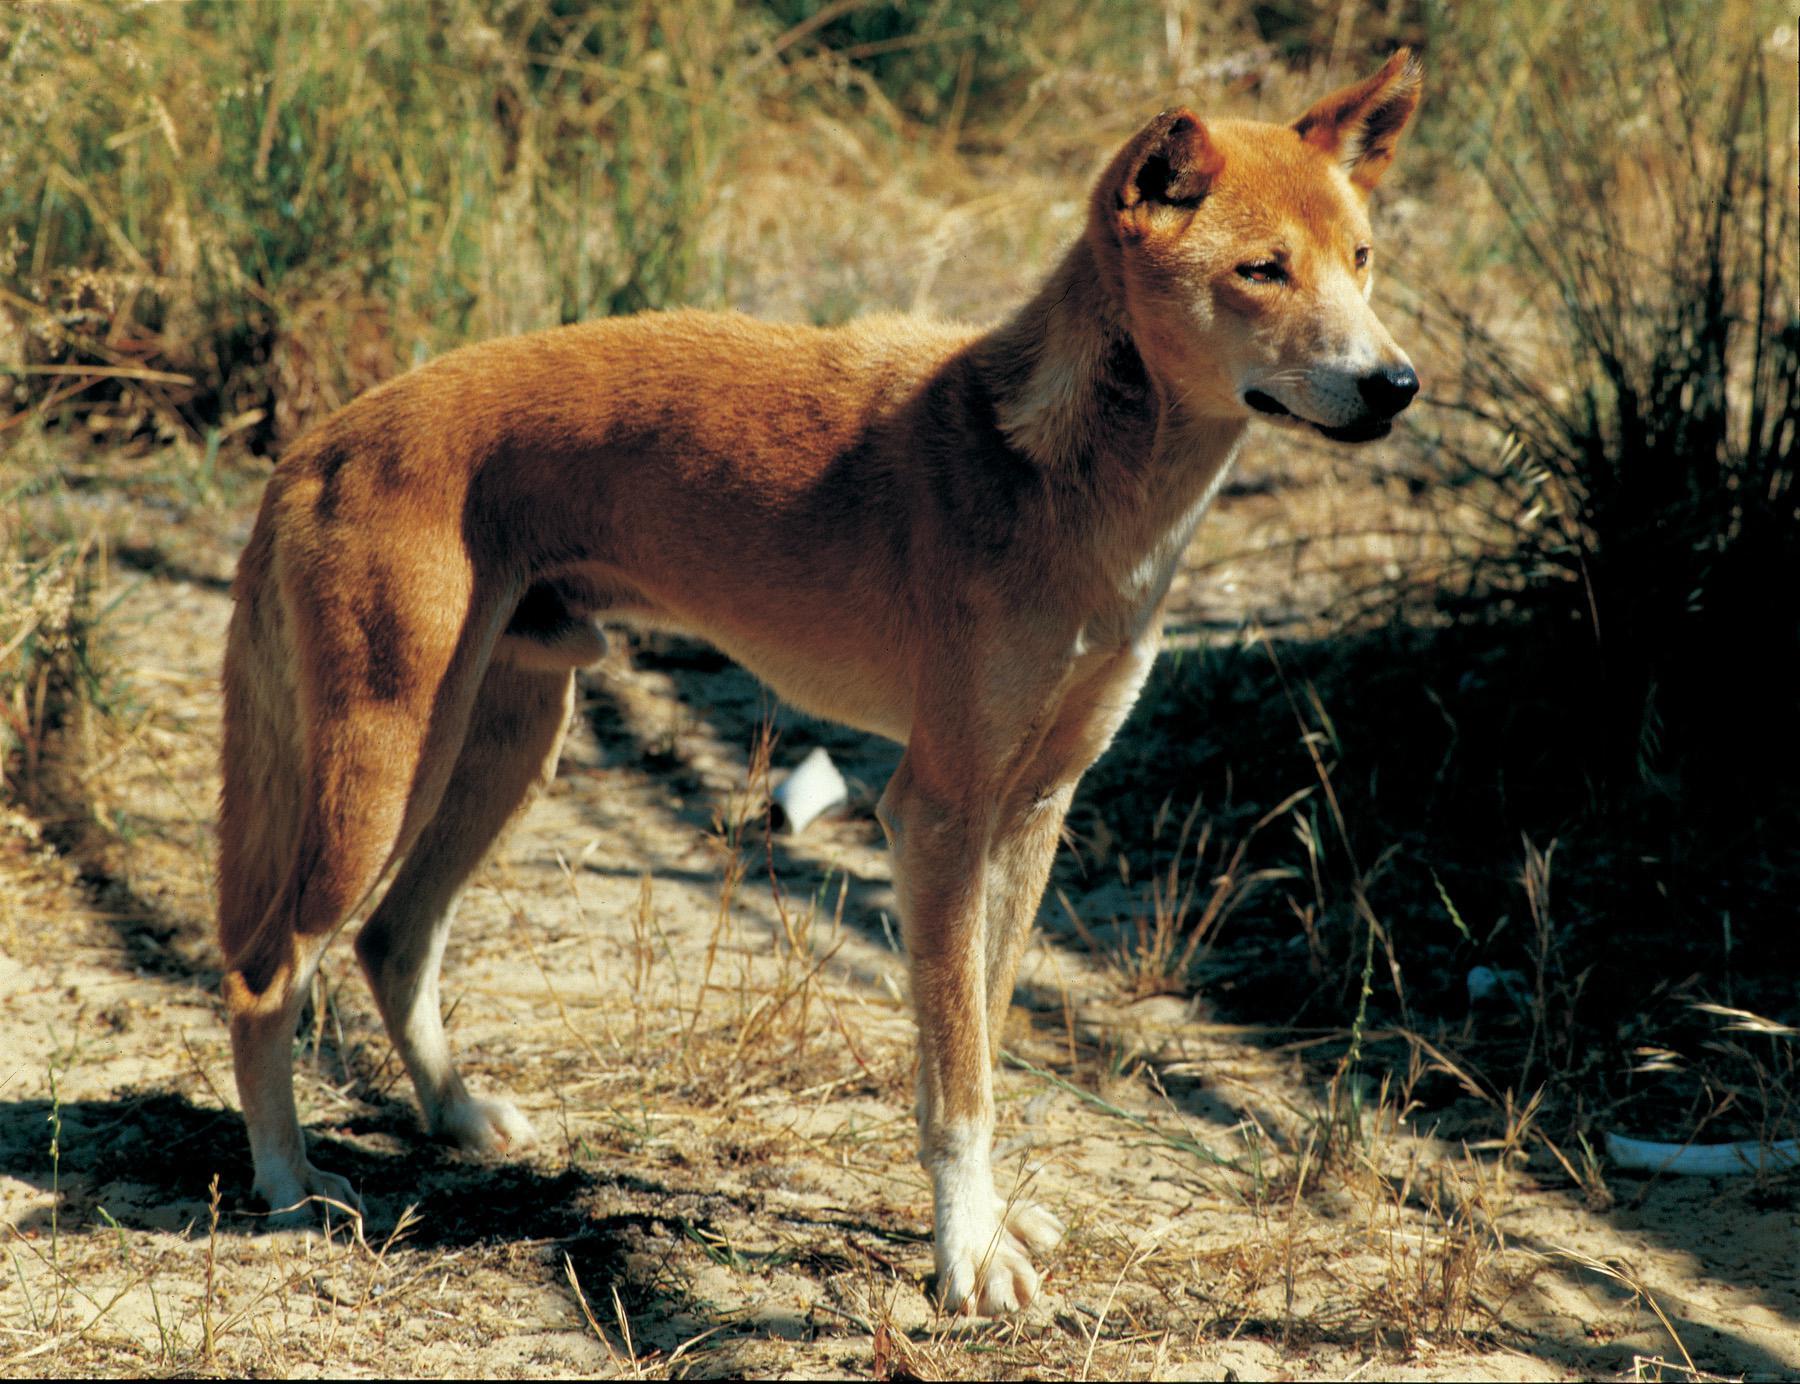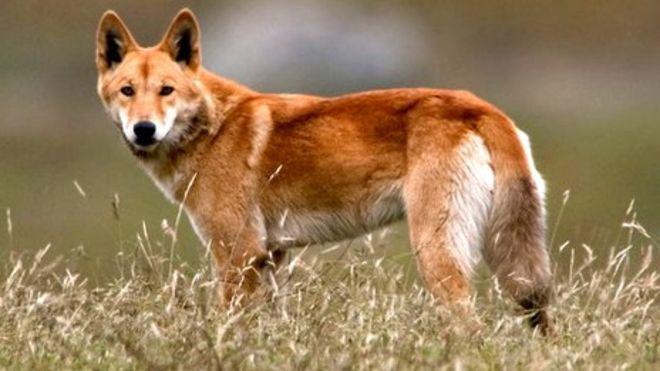The first image is the image on the left, the second image is the image on the right. Assess this claim about the two images: "A dingo is walking on red dirt in one image.". Correct or not? Answer yes or no. No. The first image is the image on the left, the second image is the image on the right. Assess this claim about the two images: "In at least one image a lone dog on a red sand surface". Correct or not? Answer yes or no. No. 